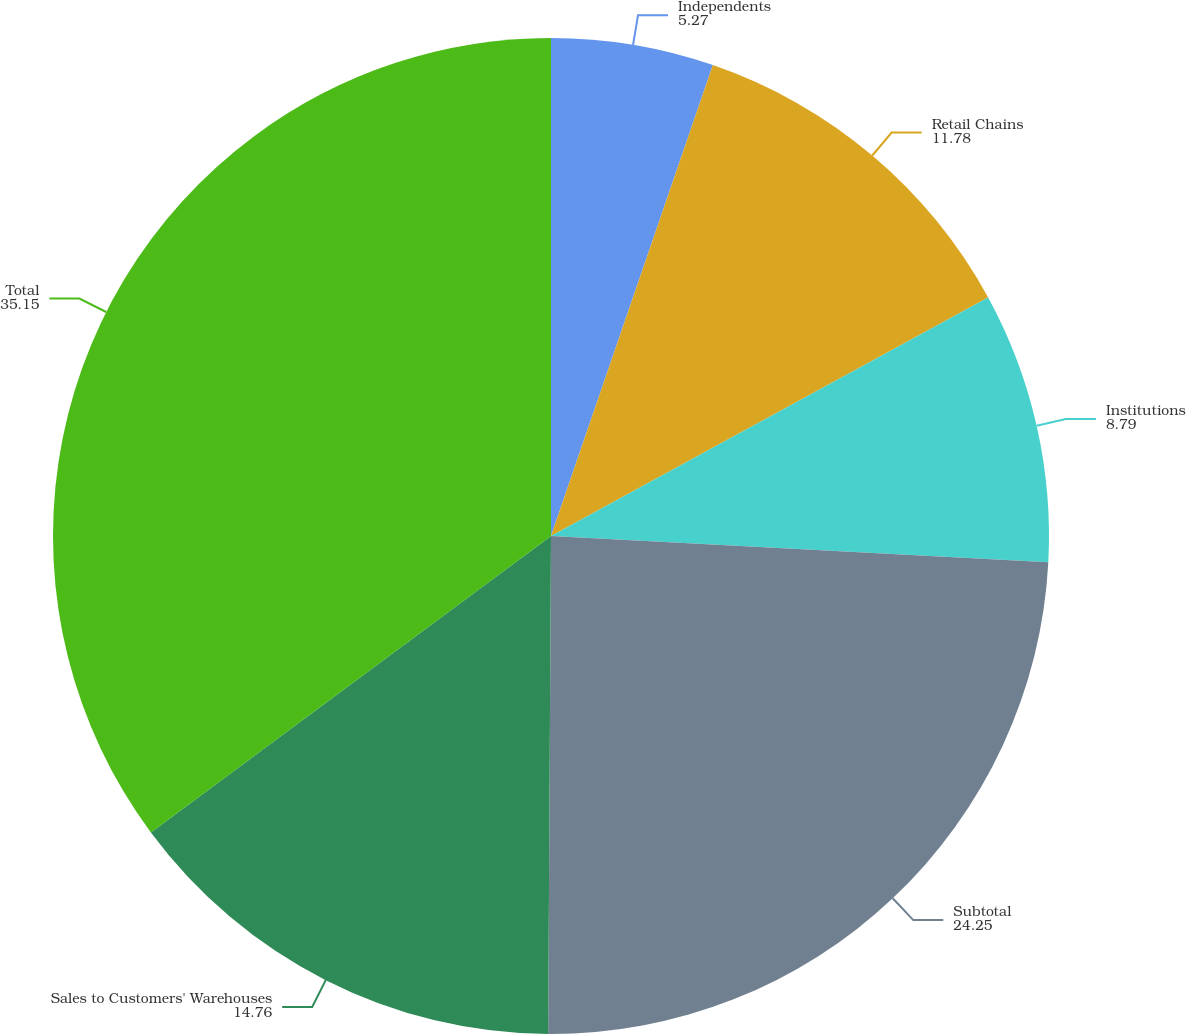<chart> <loc_0><loc_0><loc_500><loc_500><pie_chart><fcel>Independents<fcel>Retail Chains<fcel>Institutions<fcel>Subtotal<fcel>Sales to Customers' Warehouses<fcel>Total<nl><fcel>5.27%<fcel>11.78%<fcel>8.79%<fcel>24.25%<fcel>14.76%<fcel>35.15%<nl></chart> 